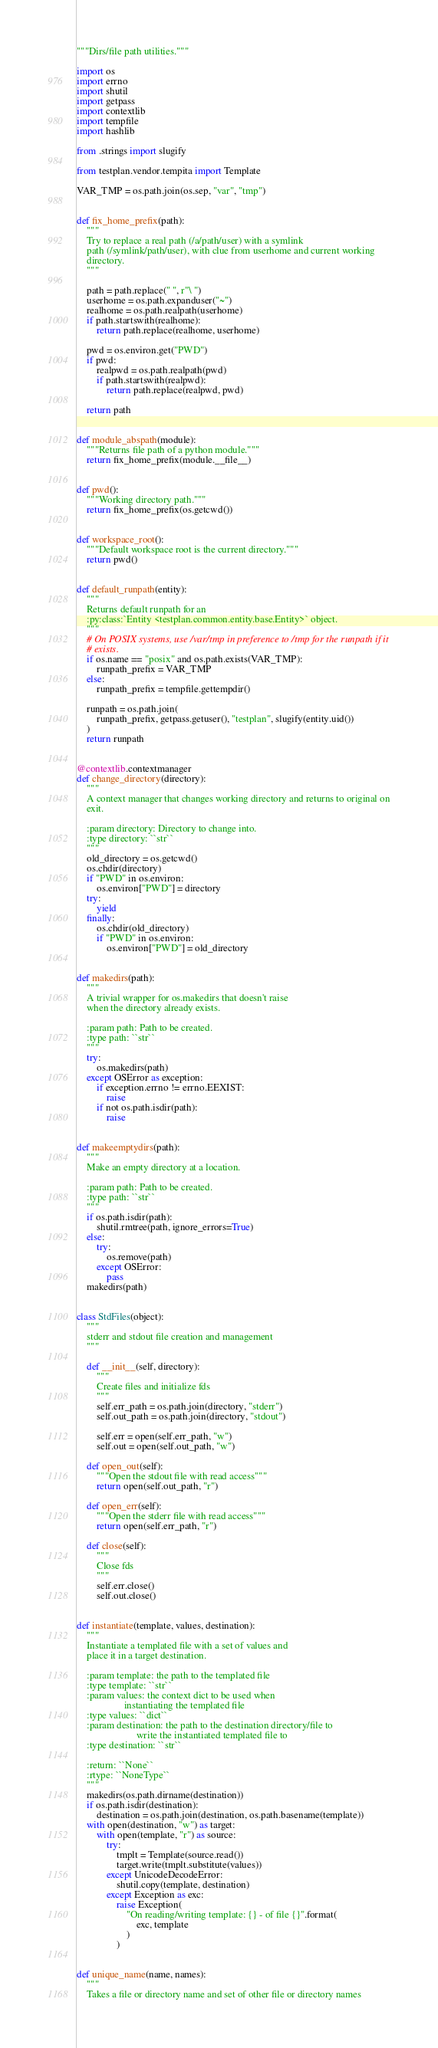<code> <loc_0><loc_0><loc_500><loc_500><_Python_>"""Dirs/file path utilities."""

import os
import errno
import shutil
import getpass
import contextlib
import tempfile
import hashlib

from .strings import slugify

from testplan.vendor.tempita import Template

VAR_TMP = os.path.join(os.sep, "var", "tmp")


def fix_home_prefix(path):
    """
    Try to replace a real path (/a/path/user) with a symlink
    path (/symlink/path/user), with clue from userhome and current working
    directory.
    """

    path = path.replace(" ", r"\ ")
    userhome = os.path.expanduser("~")
    realhome = os.path.realpath(userhome)
    if path.startswith(realhome):
        return path.replace(realhome, userhome)

    pwd = os.environ.get("PWD")
    if pwd:
        realpwd = os.path.realpath(pwd)
        if path.startswith(realpwd):
            return path.replace(realpwd, pwd)

    return path


def module_abspath(module):
    """Returns file path of a python module."""
    return fix_home_prefix(module.__file__)


def pwd():
    """Working directory path."""
    return fix_home_prefix(os.getcwd())


def workspace_root():
    """Default workspace root is the current directory."""
    return pwd()


def default_runpath(entity):
    """
    Returns default runpath for an
    :py:class:`Entity <testplan.common.entity.base.Entity>` object.
    """
    # On POSIX systems, use /var/tmp in preference to /tmp for the runpath if it
    # exists.
    if os.name == "posix" and os.path.exists(VAR_TMP):
        runpath_prefix = VAR_TMP
    else:
        runpath_prefix = tempfile.gettempdir()

    runpath = os.path.join(
        runpath_prefix, getpass.getuser(), "testplan", slugify(entity.uid())
    )
    return runpath


@contextlib.contextmanager
def change_directory(directory):
    """
    A context manager that changes working directory and returns to original on
    exit.

    :param directory: Directory to change into.
    :type directory: ``str``
    """
    old_directory = os.getcwd()
    os.chdir(directory)
    if "PWD" in os.environ:
        os.environ["PWD"] = directory
    try:
        yield
    finally:
        os.chdir(old_directory)
        if "PWD" in os.environ:
            os.environ["PWD"] = old_directory


def makedirs(path):
    """
    A trivial wrapper for os.makedirs that doesn't raise
    when the directory already exists.

    :param path: Path to be created.
    :type path: ``str``
    """
    try:
        os.makedirs(path)
    except OSError as exception:
        if exception.errno != errno.EEXIST:
            raise
        if not os.path.isdir(path):
            raise


def makeemptydirs(path):
    """
    Make an empty directory at a location.

    :param path: Path to be created.
    :type path: ``str``
    """
    if os.path.isdir(path):
        shutil.rmtree(path, ignore_errors=True)
    else:
        try:
            os.remove(path)
        except OSError:
            pass
    makedirs(path)


class StdFiles(object):
    """
    stderr and stdout file creation and management
    """

    def __init__(self, directory):
        """
        Create files and initialize fds
        """
        self.err_path = os.path.join(directory, "stderr")
        self.out_path = os.path.join(directory, "stdout")

        self.err = open(self.err_path, "w")
        self.out = open(self.out_path, "w")

    def open_out(self):
        """Open the stdout file with read access"""
        return open(self.out_path, "r")

    def open_err(self):
        """Open the stderr file with read access"""
        return open(self.err_path, "r")

    def close(self):
        """
        Close fds
        """
        self.err.close()
        self.out.close()


def instantiate(template, values, destination):
    """
    Instantiate a templated file with a set of values and
    place it in a target destination.

    :param template: the path to the templated file
    :type template: ``str``
    :param values: the context dict to be used when
                   instantiating the templated file
    :type values: ``dict``
    :param destination: the path to the destination directory/file to
                        write the instantiated templated file to
    :type destination: ``str``

    :return: ``None``
    :rtype: ``NoneType``
    """
    makedirs(os.path.dirname(destination))
    if os.path.isdir(destination):
        destination = os.path.join(destination, os.path.basename(template))
    with open(destination, "w") as target:
        with open(template, "r") as source:
            try:
                tmplt = Template(source.read())
                target.write(tmplt.substitute(values))
            except UnicodeDecodeError:
                shutil.copy(template, destination)
            except Exception as exc:
                raise Exception(
                    "On reading/writing template: {} - of file {}".format(
                        exc, template
                    )
                )


def unique_name(name, names):
    """
    Takes a file or directory name and set of other file or directory names
</code> 